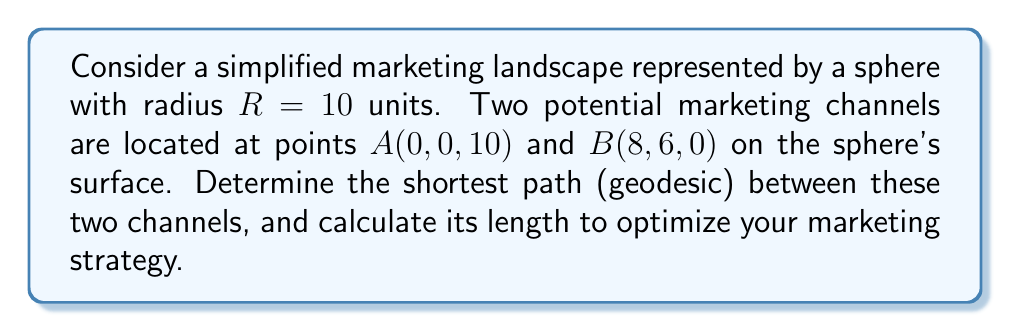Give your solution to this math problem. To solve this problem, we'll follow these steps:

1) First, recall that on a sphere, the geodesic (shortest path) between two points is always along a great circle.

2) To find the length of this geodesic, we need to calculate the central angle $\theta$ between the two points and then use the arc length formula.

3) The central angle can be found using the dot product of the position vectors of points A and B:

   $$\cos \theta = \frac{\vec{A} \cdot \vec{B}}{|\vec{A}||\vec{B}|}$$

4) Let's calculate this:
   
   $\vec{A} = (0, 0, 10)$
   $\vec{B} = (8, 6, 0)$
   
   $\vec{A} \cdot \vec{B} = 0 \cdot 8 + 0 \cdot 6 + 10 \cdot 0 = 0$
   
   $|\vec{A}| = |\vec{B}| = R = 10$

5) Substituting into the formula:

   $$\cos \theta = \frac{0}{10 \cdot 10} = 0$$

6) Therefore, $\theta = \arccos(0) = \frac{\pi}{2}$ radians or 90°.

7) The arc length $s$ of a great circle on a sphere is given by:

   $$s = R\theta$$

8) Substituting our values:

   $$s = 10 \cdot \frac{\pi}{2} = 5\pi$$

This means the shortest path between the two marketing channels is along a quarter of a great circle, with a length of $5\pi$ units.
Answer: $5\pi$ units 